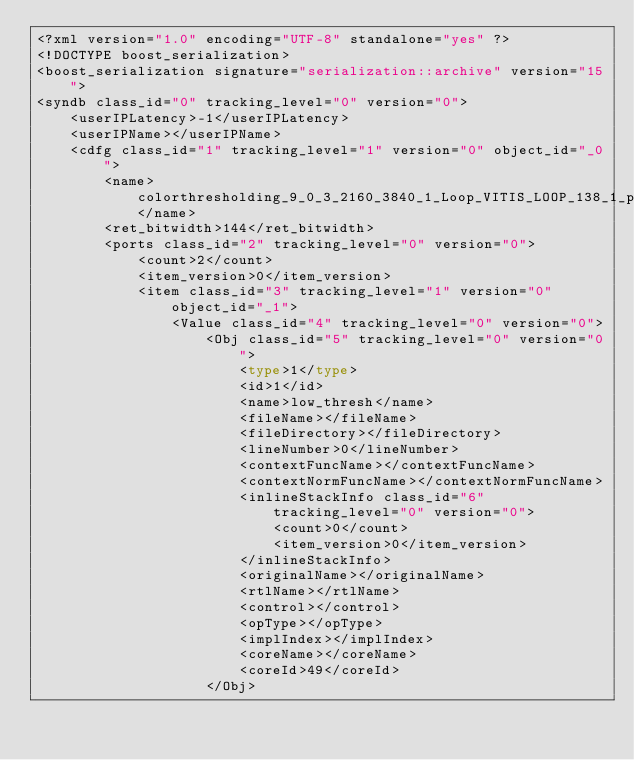Convert code to text. <code><loc_0><loc_0><loc_500><loc_500><_Ada_><?xml version="1.0" encoding="UTF-8" standalone="yes" ?>
<!DOCTYPE boost_serialization>
<boost_serialization signature="serialization::archive" version="15">
<syndb class_id="0" tracking_level="0" version="0">
	<userIPLatency>-1</userIPLatency>
	<userIPName></userIPName>
	<cdfg class_id="1" tracking_level="1" version="0" object_id="_0">
		<name>colorthresholding_9_0_3_2160_3840_1_Loop_VITIS_LOOP_138_1_proc</name>
		<ret_bitwidth>144</ret_bitwidth>
		<ports class_id="2" tracking_level="0" version="0">
			<count>2</count>
			<item_version>0</item_version>
			<item class_id="3" tracking_level="1" version="0" object_id="_1">
				<Value class_id="4" tracking_level="0" version="0">
					<Obj class_id="5" tracking_level="0" version="0">
						<type>1</type>
						<id>1</id>
						<name>low_thresh</name>
						<fileName></fileName>
						<fileDirectory></fileDirectory>
						<lineNumber>0</lineNumber>
						<contextFuncName></contextFuncName>
						<contextNormFuncName></contextNormFuncName>
						<inlineStackInfo class_id="6" tracking_level="0" version="0">
							<count>0</count>
							<item_version>0</item_version>
						</inlineStackInfo>
						<originalName></originalName>
						<rtlName></rtlName>
						<control></control>
						<opType></opType>
						<implIndex></implIndex>
						<coreName></coreName>
						<coreId>49</coreId>
					</Obj></code> 